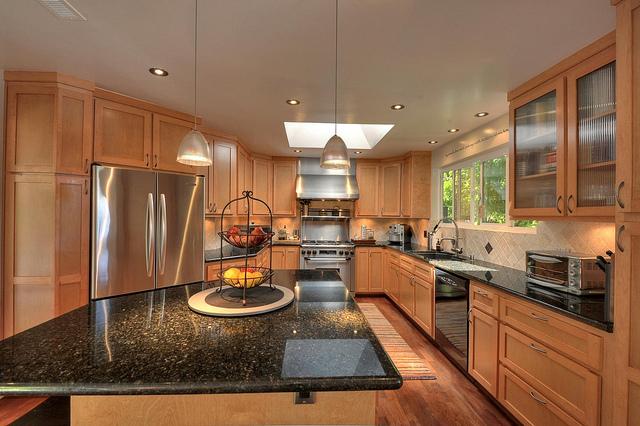Are all the cabinets opaque?
Short answer required. No. Is anybody cooking in this kitchen?
Answer briefly. No. Is this an old-fashioned kitchen?
Answer briefly. No. What kind of room is this?
Be succinct. Kitchen. 